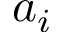Convert formula to latex. <formula><loc_0><loc_0><loc_500><loc_500>a _ { i }</formula> 